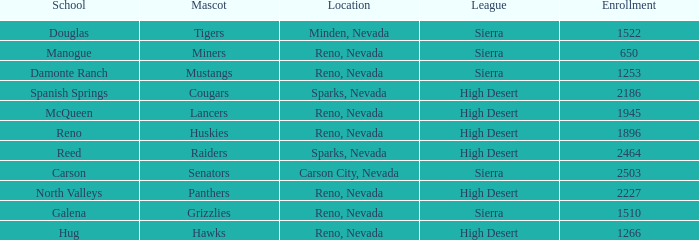Which school has the Raiders as their mascot? Reed. 